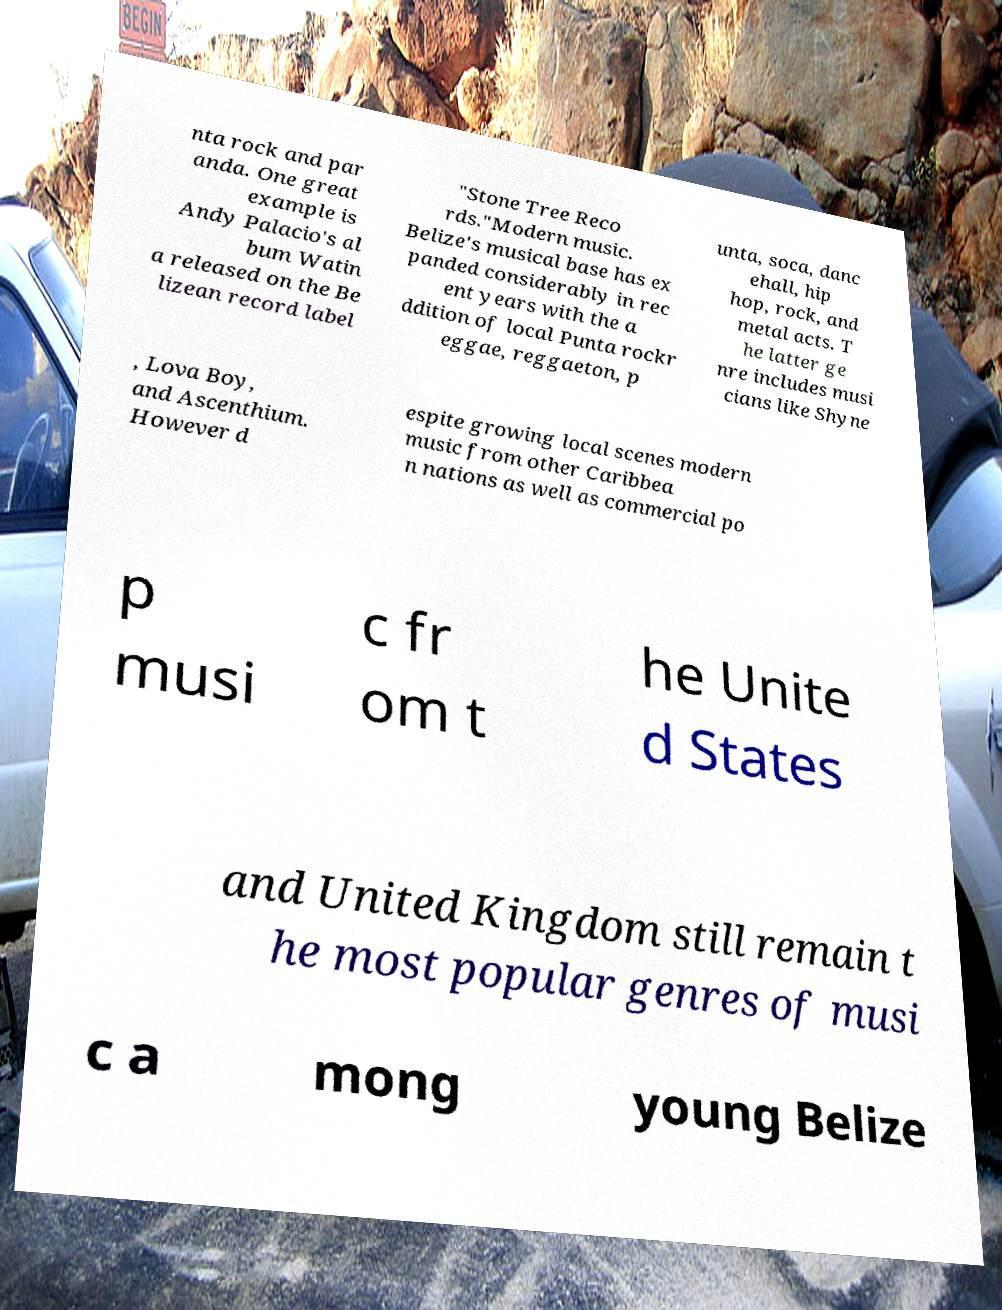Please read and relay the text visible in this image. What does it say? nta rock and par anda. One great example is Andy Palacio's al bum Watin a released on the Be lizean record label "Stone Tree Reco rds."Modern music. Belize's musical base has ex panded considerably in rec ent years with the a ddition of local Punta rockr eggae, reggaeton, p unta, soca, danc ehall, hip hop, rock, and metal acts. T he latter ge nre includes musi cians like Shyne , Lova Boy, and Ascenthium. However d espite growing local scenes modern music from other Caribbea n nations as well as commercial po p musi c fr om t he Unite d States and United Kingdom still remain t he most popular genres of musi c a mong young Belize 